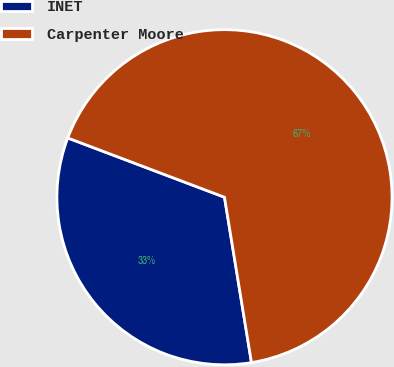Convert chart. <chart><loc_0><loc_0><loc_500><loc_500><pie_chart><fcel>INET<fcel>Carpenter Moore<nl><fcel>33.33%<fcel>66.67%<nl></chart> 